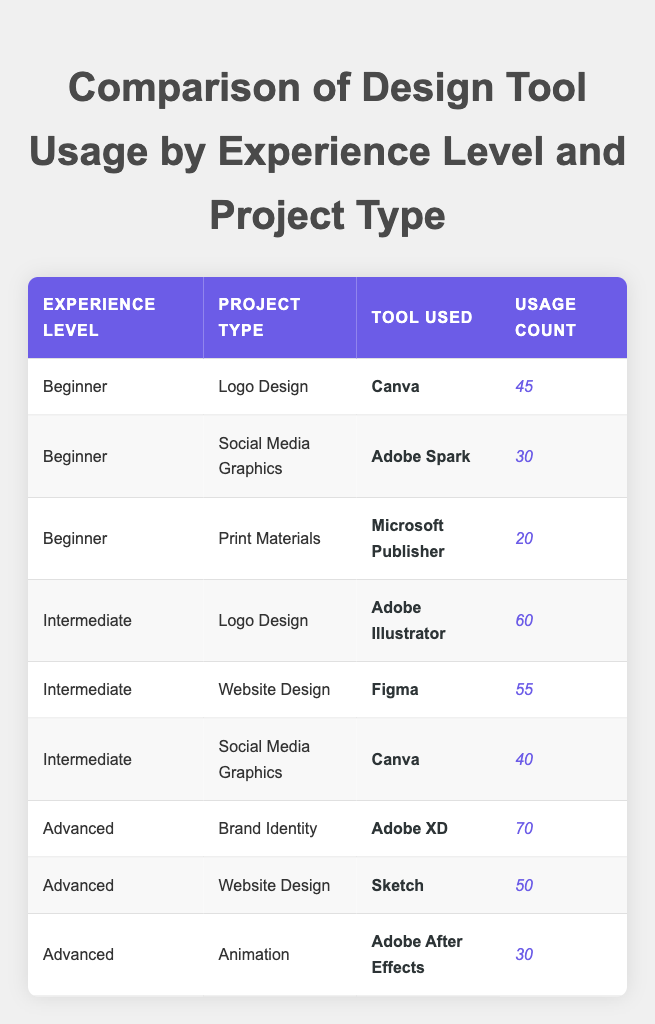What design tool is used most frequently by beginners for logo design? In the table, we can see that beginners used "Canva" 45 times for logo design, which is the highest usage compared to other tools listed under the beginner level for logo design.
Answer: Canva What is the total usage count for intermediate level designers across all project types? The total usage count for intermediate level designers can be calculated by summing individual counts: 60 (Logo Design) + 55 (Website Design) + 40 (Social Media Graphics) = 155.
Answer: 155 Does an advanced designer use Canva for any project type? By checking the table, we see there are no entries for advanced designers using Canva for any project type, hence the answer is no.
Answer: No Which project type has the highest tool usage among advanced designers? From the table, the highest usage count for advanced designers is for "Brand Identity," using "Adobe XD" with a count of 70.
Answer: Brand Identity What is the average usage count for social media graphics projects? The average can be calculated by looking at the usage counts for the relevant projects: 30 (Beginner) + 40 (Intermediate) = 70, then we divide by the number of entries (2), thus 70/2 = 35.
Answer: 35 Is Adobe After Effects used by beginners for any project type? There are no entries in the table showing beginners using Adobe After Effects, so the answer is no.
Answer: No How many more times is Adobe Illustrator used than Canva for social media graphics by intermediate designers? In the table, Canva is used 40 times for social media graphics, while Adobe Illustrator is not used in this category. The difference is therefore 0 - 40 = -40, indicating that Canva is used 40 more times.
Answer: 40 more times Which tool is used for print materials by beginners, and how does its usage count compare to the highest count for a single tool? Beginners used "Microsoft Publisher" for print materials with a usage count of 20. The highest single tool count is "Adobe XD" at 70, making Microsoft Publisher's usage 50 counts lower.
Answer: 50 counts lower What is the total number of usage counts for all project types by advanced designers? The total for advanced designers is calculated as follows: 70 (Brand Identity) + 50 (Website Design) + 30 (Animation) = 150.
Answer: 150 